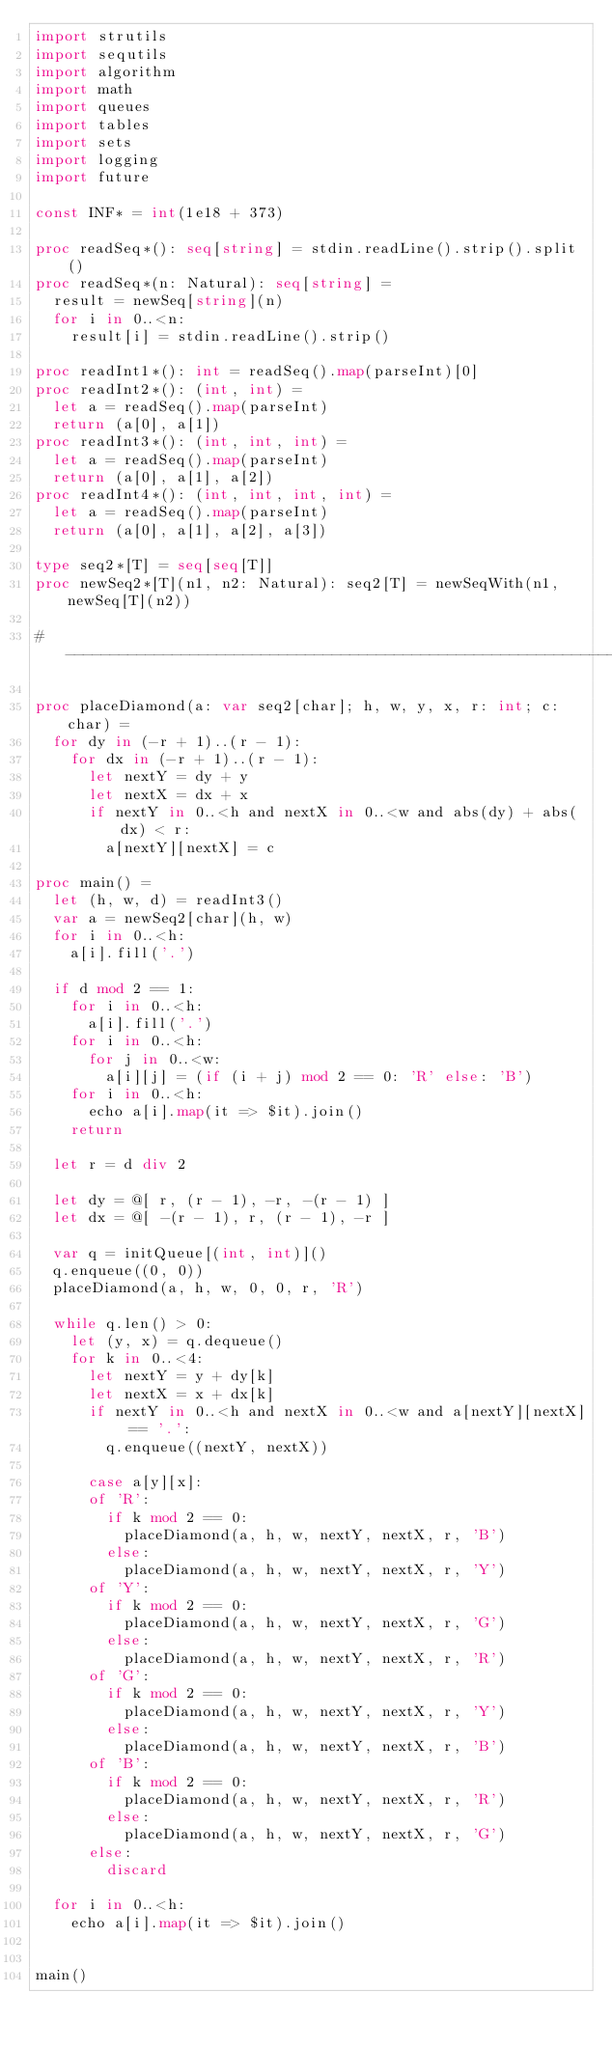<code> <loc_0><loc_0><loc_500><loc_500><_Nim_>import strutils
import sequtils
import algorithm
import math
import queues
import tables
import sets
import logging
import future

const INF* = int(1e18 + 373)

proc readSeq*(): seq[string] = stdin.readLine().strip().split()
proc readSeq*(n: Natural): seq[string] =
  result = newSeq[string](n)
  for i in 0..<n:
    result[i] = stdin.readLine().strip()

proc readInt1*(): int = readSeq().map(parseInt)[0]
proc readInt2*(): (int, int) =
  let a = readSeq().map(parseInt)
  return (a[0], a[1])
proc readInt3*(): (int, int, int) =
  let a = readSeq().map(parseInt)
  return (a[0], a[1], a[2])
proc readInt4*(): (int, int, int, int) =
  let a = readSeq().map(parseInt)
  return (a[0], a[1], a[2], a[3])

type seq2*[T] = seq[seq[T]]
proc newSeq2*[T](n1, n2: Natural): seq2[T] = newSeqWith(n1, newSeq[T](n2))

#------------------------------------------------------------------------------#

proc placeDiamond(a: var seq2[char]; h, w, y, x, r: int; c: char) =
  for dy in (-r + 1)..(r - 1):
    for dx in (-r + 1)..(r - 1):
      let nextY = dy + y
      let nextX = dx + x
      if nextY in 0..<h and nextX in 0..<w and abs(dy) + abs(dx) < r:
        a[nextY][nextX] = c

proc main() =
  let (h, w, d) = readInt3()
  var a = newSeq2[char](h, w)
  for i in 0..<h:
    a[i].fill('.')

  if d mod 2 == 1:
    for i in 0..<h:
      a[i].fill('.')
    for i in 0..<h:
      for j in 0..<w:
        a[i][j] = (if (i + j) mod 2 == 0: 'R' else: 'B')
    for i in 0..<h:
      echo a[i].map(it => $it).join()
    return

  let r = d div 2

  let dy = @[ r, (r - 1), -r, -(r - 1) ]
  let dx = @[ -(r - 1), r, (r - 1), -r ]

  var q = initQueue[(int, int)]()
  q.enqueue((0, 0))
  placeDiamond(a, h, w, 0, 0, r, 'R')

  while q.len() > 0:
    let (y, x) = q.dequeue()
    for k in 0..<4:
      let nextY = y + dy[k]
      let nextX = x + dx[k]
      if nextY in 0..<h and nextX in 0..<w and a[nextY][nextX] == '.':
        q.enqueue((nextY, nextX))

      case a[y][x]:
      of 'R':
        if k mod 2 == 0:
          placeDiamond(a, h, w, nextY, nextX, r, 'B')
        else:
          placeDiamond(a, h, w, nextY, nextX, r, 'Y')
      of 'Y':
        if k mod 2 == 0:
          placeDiamond(a, h, w, nextY, nextX, r, 'G')
        else:
          placeDiamond(a, h, w, nextY, nextX, r, 'R')
      of 'G':
        if k mod 2 == 0:
          placeDiamond(a, h, w, nextY, nextX, r, 'Y')
        else:
          placeDiamond(a, h, w, nextY, nextX, r, 'B')
      of 'B':
        if k mod 2 == 0:
          placeDiamond(a, h, w, nextY, nextX, r, 'R')
        else:
          placeDiamond(a, h, w, nextY, nextX, r, 'G')
      else:
        discard

  for i in 0..<h:
    echo a[i].map(it => $it).join()


main()

</code> 